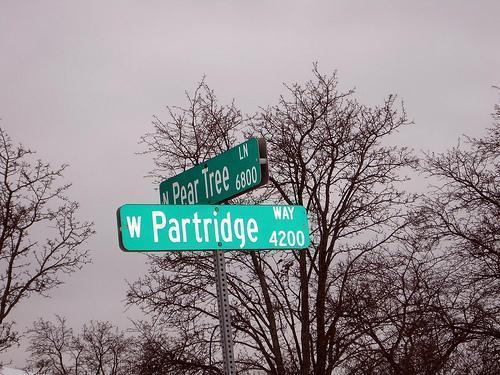How many signs?
Give a very brief answer. 2. 